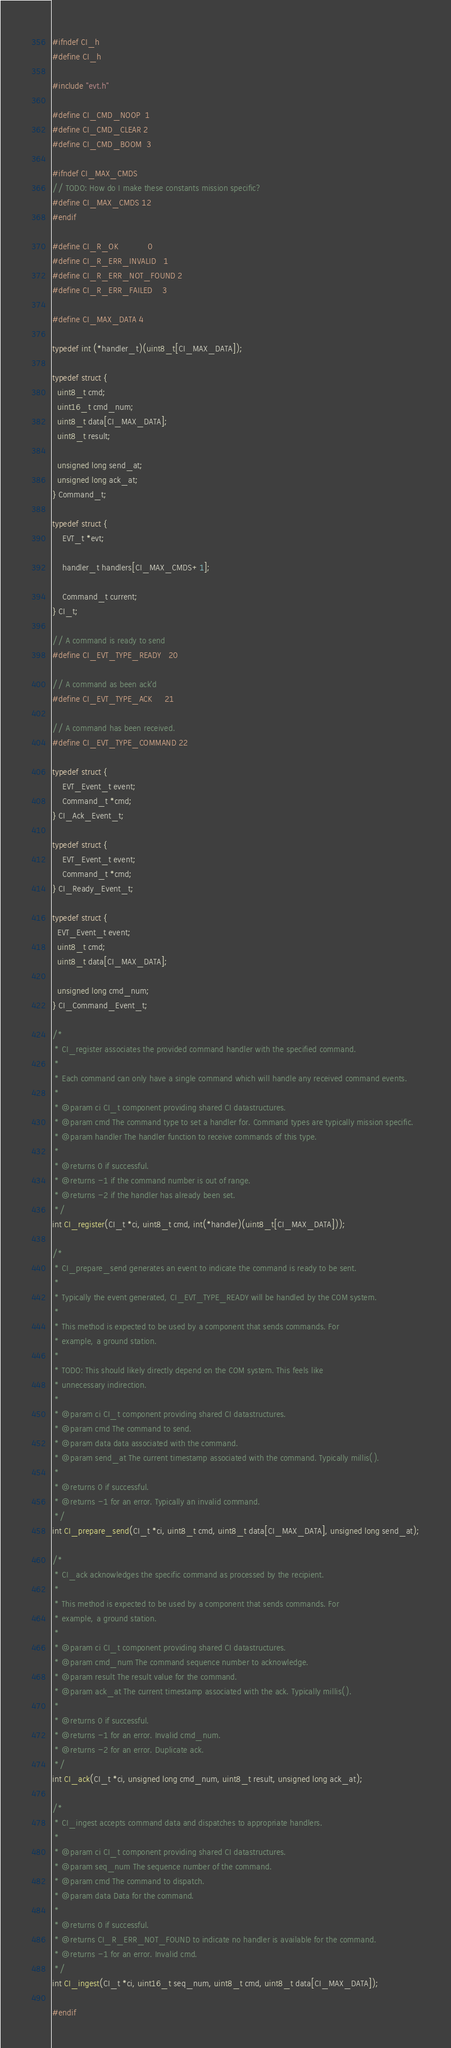Convert code to text. <code><loc_0><loc_0><loc_500><loc_500><_C_>#ifndef CI_h
#define CI_h

#include "evt.h"

#define CI_CMD_NOOP  1
#define CI_CMD_CLEAR 2
#define CI_CMD_BOOM  3

#ifndef CI_MAX_CMDS
// TODO: How do I make these constants mission specific?
#define CI_MAX_CMDS 12
#endif

#define CI_R_OK            0
#define CI_R_ERR_INVALID   1 
#define CI_R_ERR_NOT_FOUND 2
#define CI_R_ERR_FAILED    3

#define CI_MAX_DATA 4

typedef int (*handler_t)(uint8_t[CI_MAX_DATA]);

typedef struct {
  uint8_t cmd;
  uint16_t cmd_num;
  uint8_t data[CI_MAX_DATA];
  uint8_t result;

  unsigned long send_at;
  unsigned long ack_at;
} Command_t;

typedef struct {
    EVT_t *evt;

    handler_t handlers[CI_MAX_CMDS+1];

    Command_t current;
} CI_t;

// A command is ready to send
#define CI_EVT_TYPE_READY   20

// A command as been ack'd
#define CI_EVT_TYPE_ACK     21

// A command has been received.
#define CI_EVT_TYPE_COMMAND 22

typedef struct {
    EVT_Event_t event;
    Command_t *cmd;
} CI_Ack_Event_t;

typedef struct {
    EVT_Event_t event;
    Command_t *cmd;
} CI_Ready_Event_t;

typedef struct {
  EVT_Event_t event;
  uint8_t cmd;
  uint8_t data[CI_MAX_DATA];

  unsigned long cmd_num;
} CI_Command_Event_t;

/*
 * CI_register associates the provided command handler with the specified command.
 * 
 * Each command can only have a single command which will handle any received command events.
 * 
 * @param ci CI_t component providing shared CI datastructures.
 * @param cmd The command type to set a handler for. Command types are typically mission specific.
 * @param handler The handler function to receive commands of this type.
 * 
 * @returns 0 if successful. 
 * @returns -1 if the command number is out of range.
 * @returns -2 if the handler has already been set.
 */
int CI_register(CI_t *ci, uint8_t cmd, int(*handler)(uint8_t[CI_MAX_DATA]));

/*
 * CI_prepare_send generates an event to indicate the command is ready to be sent.
 * 
 * Typically the event generated, CI_EVT_TYPE_READY will be handled by the COM system.
 * 
 * This method is expected to be used by a component that sends commands. For
 * example, a ground station.
 * 
 * TODO: This should likely directly depend on the COM system. This feels like
 * unnecessary indirection.
 * 
 * @param ci CI_t component providing shared CI datastructures.
 * @param cmd The command to send.
 * @param data data associated with the command.
 * @param send_at The current timestamp associated with the command. Typically millis().
 * 
 * @returns 0 if successful. 
 * @returns -1 for an error. Typically an invalid command.
 */
int CI_prepare_send(CI_t *ci, uint8_t cmd, uint8_t data[CI_MAX_DATA], unsigned long send_at);

/*
 * CI_ack acknowledges the specific command as processed by the recipient.
 * 
 * This method is expected to be used by a component that sends commands. For
 * example, a ground station.
 * 
 * @param ci CI_t component providing shared CI datastructures.
 * @param cmd_num The command sequence number to acknowledge.
 * @param result The result value for the command.
 * @param ack_at The current timestamp associated with the ack. Typically millis().
 * 
 * @returns 0 if successful. 
 * @returns -1 for an error. Invalid cmd_num.
 * @returns -2 for an error. Duplicate ack.
 */
int CI_ack(CI_t *ci, unsigned long cmd_num, uint8_t result, unsigned long ack_at);

/*
 * CI_ingest accepts command data and dispatches to appropriate handlers.
 * 
 * @param ci CI_t component providing shared CI datastructures.
 * @param seq_num The sequence number of the command. 
 * @param cmd The command to dispatch.
 * @param data Data for the command.
 * 
 * @returns 0 if successful. 
 * @returns CI_R_ERR_NOT_FOUND to indicate no handler is available for the command.
 * @returns -1 for an error. Invalid cmd.
 */
int CI_ingest(CI_t *ci, uint16_t seq_num, uint8_t cmd, uint8_t data[CI_MAX_DATA]);

#endif</code> 